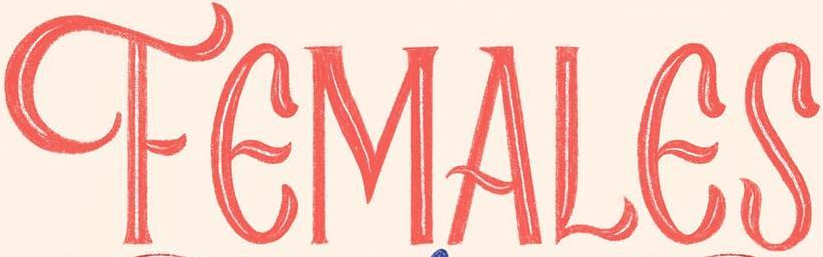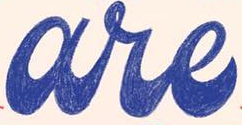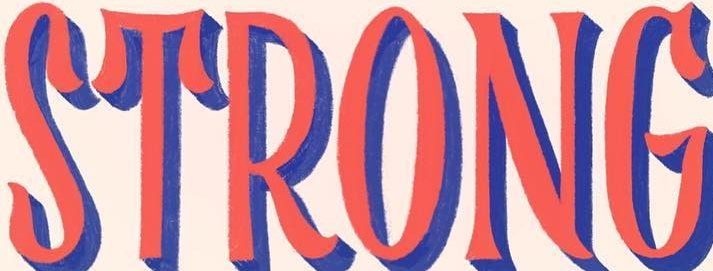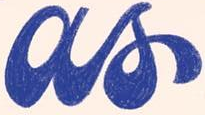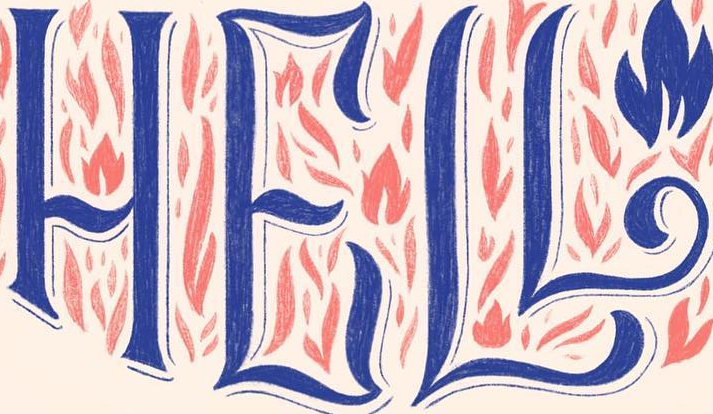Identify the words shown in these images in order, separated by a semicolon. FEMALES; are; STRONG; as; HELL 